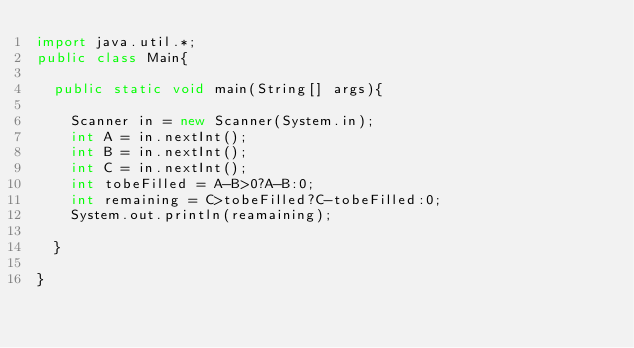Convert code to text. <code><loc_0><loc_0><loc_500><loc_500><_Java_>import java.util.*;
public class Main{
  
  public static void main(String[] args){
    
    Scanner in = new Scanner(System.in);
    int A = in.nextInt();
    int B = in.nextInt();
    int C = in.nextInt();
    int tobeFilled = A-B>0?A-B:0;
    int remaining = C>tobeFilled?C-tobeFilled:0;
    System.out.println(reamaining);
    
  }
  
}</code> 